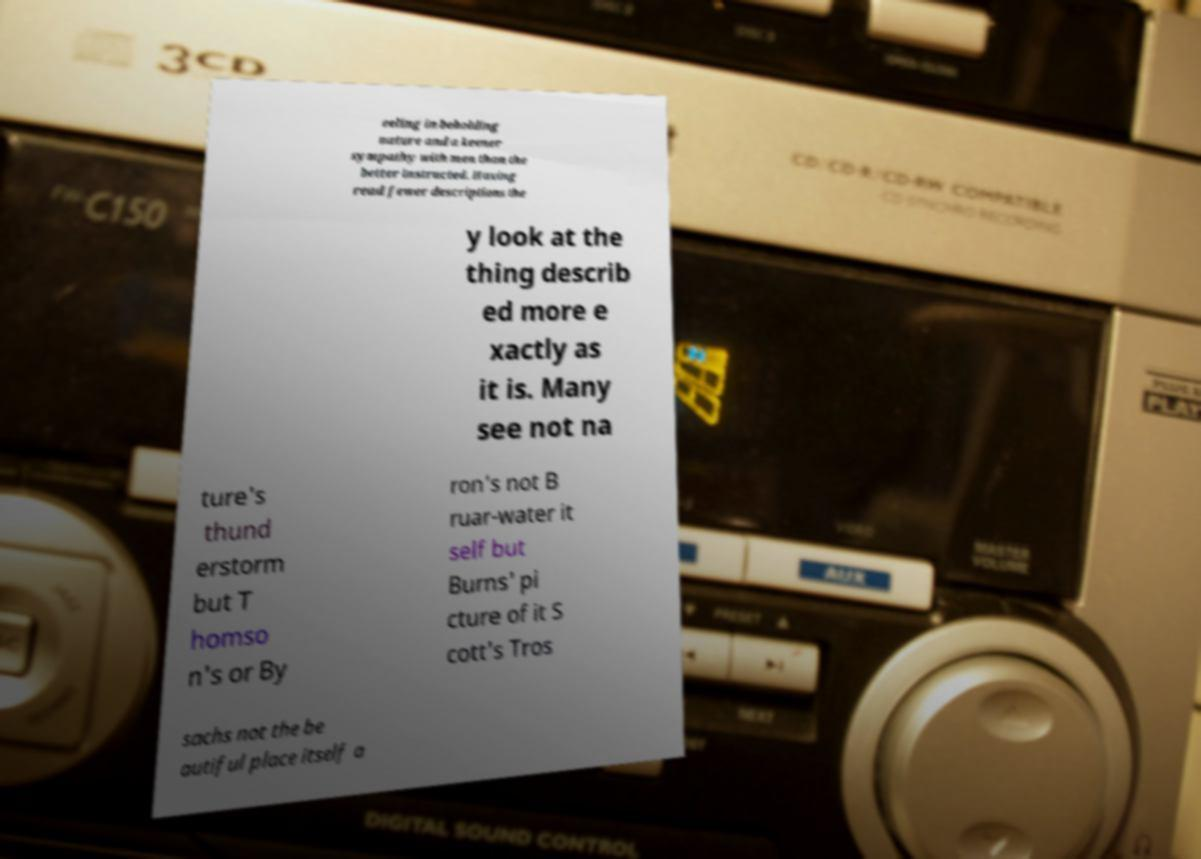I need the written content from this picture converted into text. Can you do that? eeling in beholding nature and a keener sympathy with men than the better instructed. Having read fewer descriptions the y look at the thing describ ed more e xactly as it is. Many see not na ture's thund erstorm but T homso n's or By ron's not B ruar-water it self but Burns' pi cture of it S cott's Tros sachs not the be autiful place itself a 